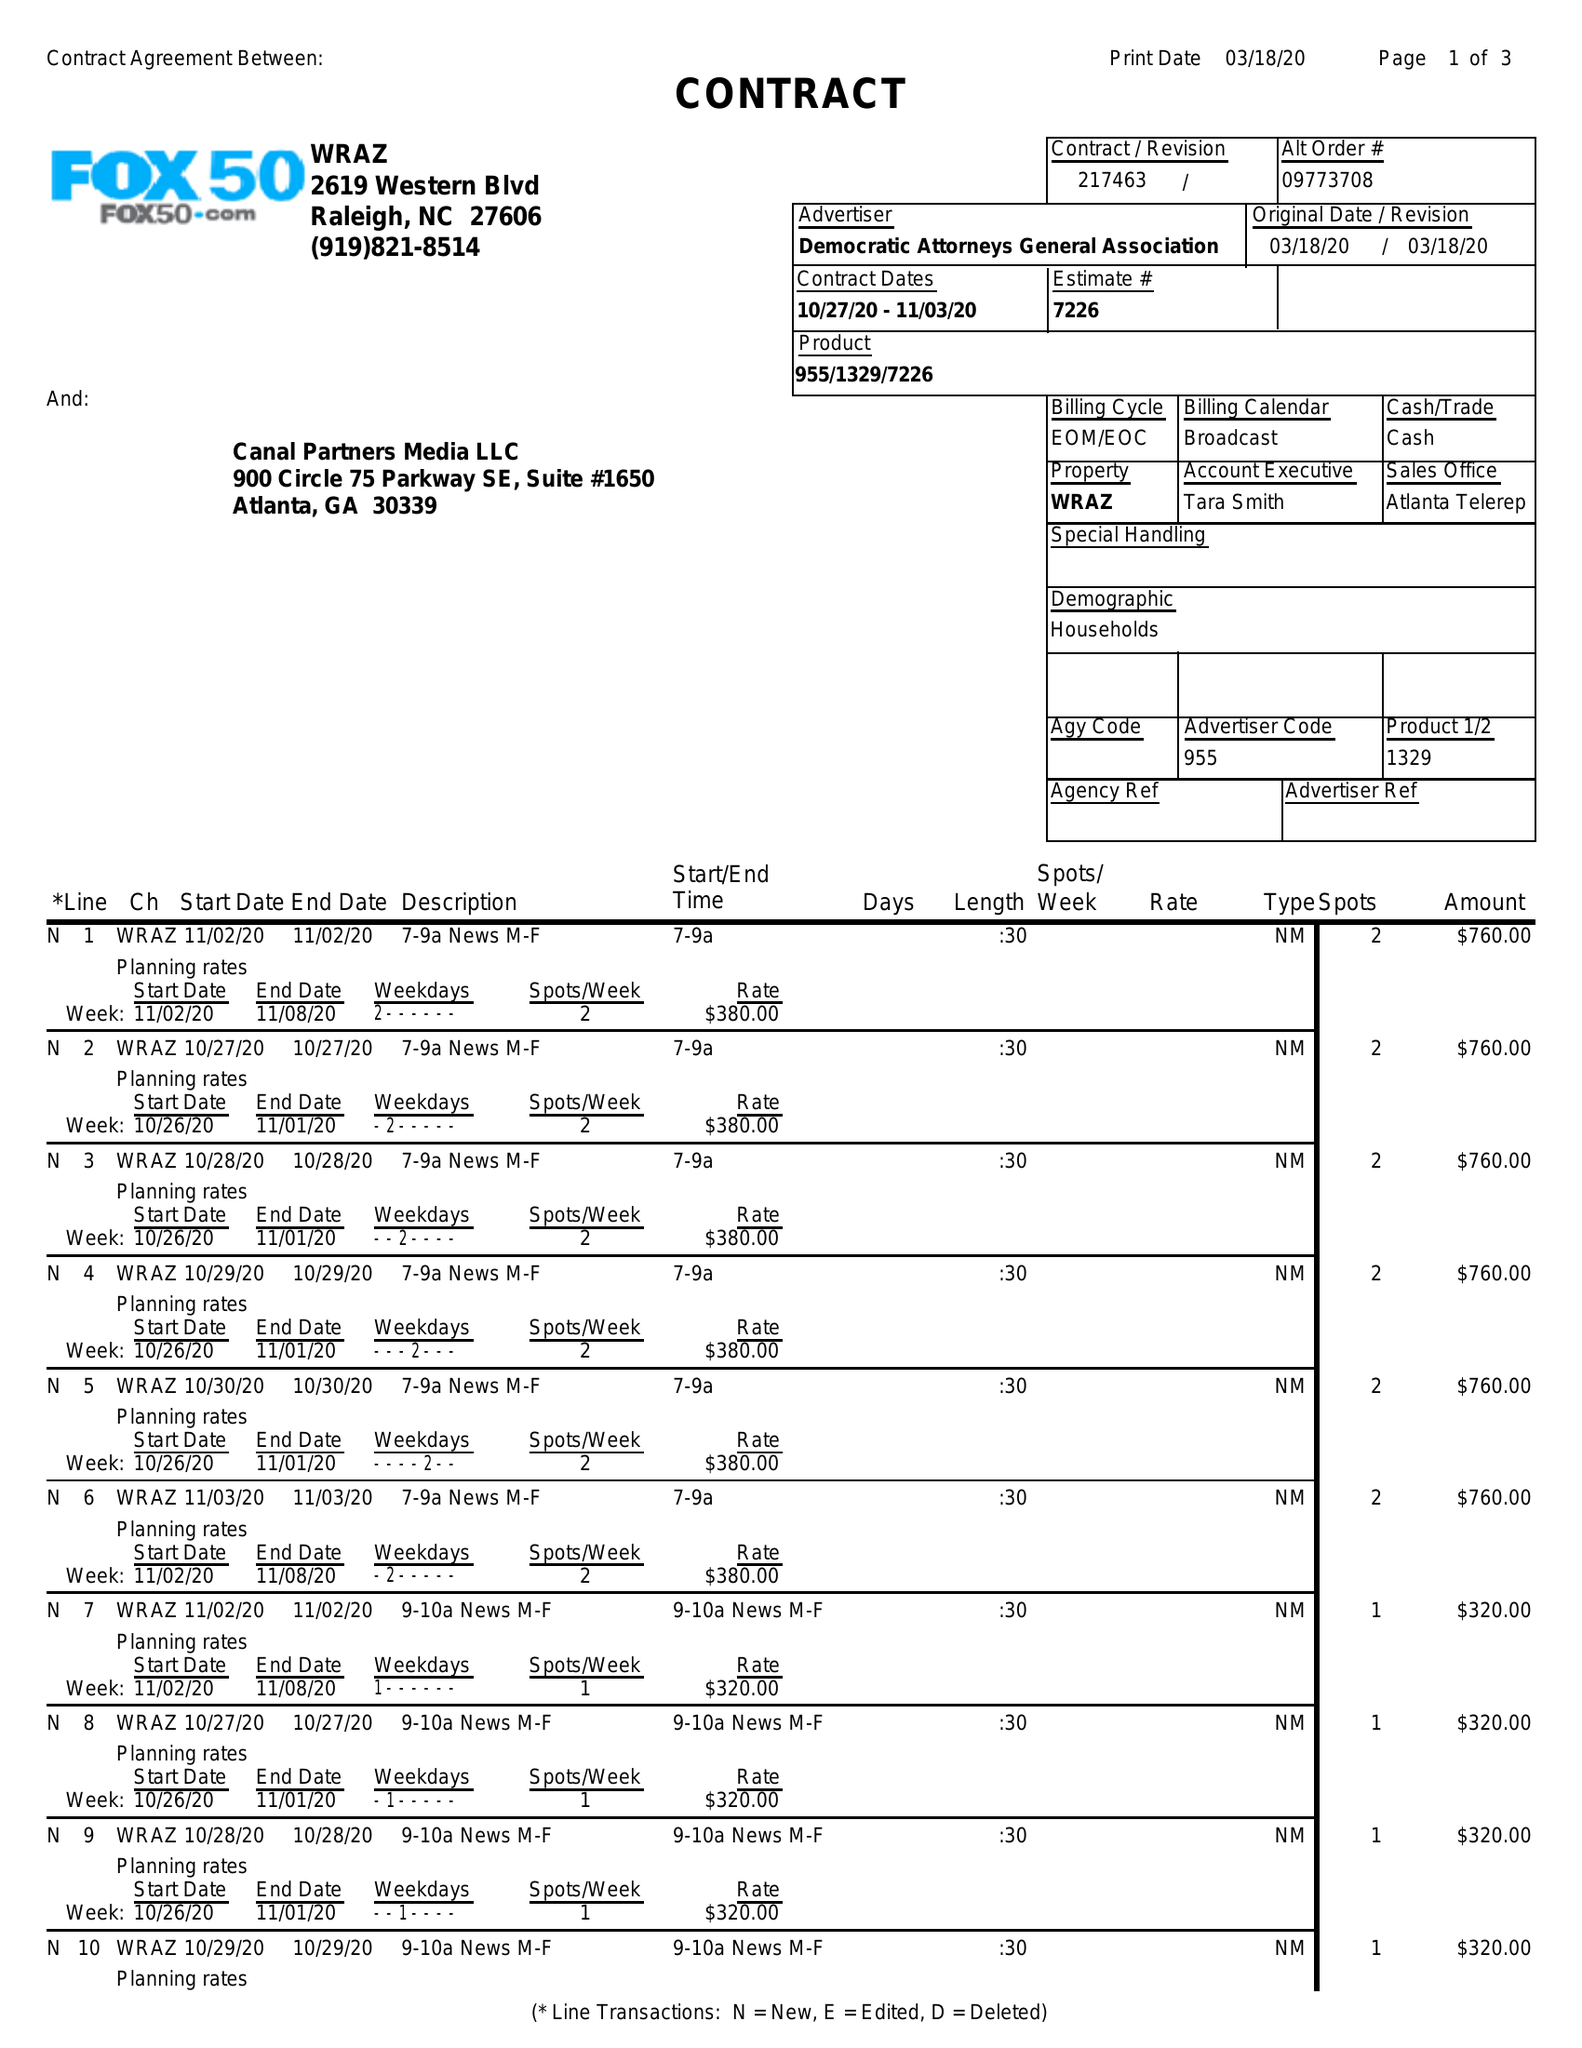What is the value for the contract_num?
Answer the question using a single word or phrase. 217463 